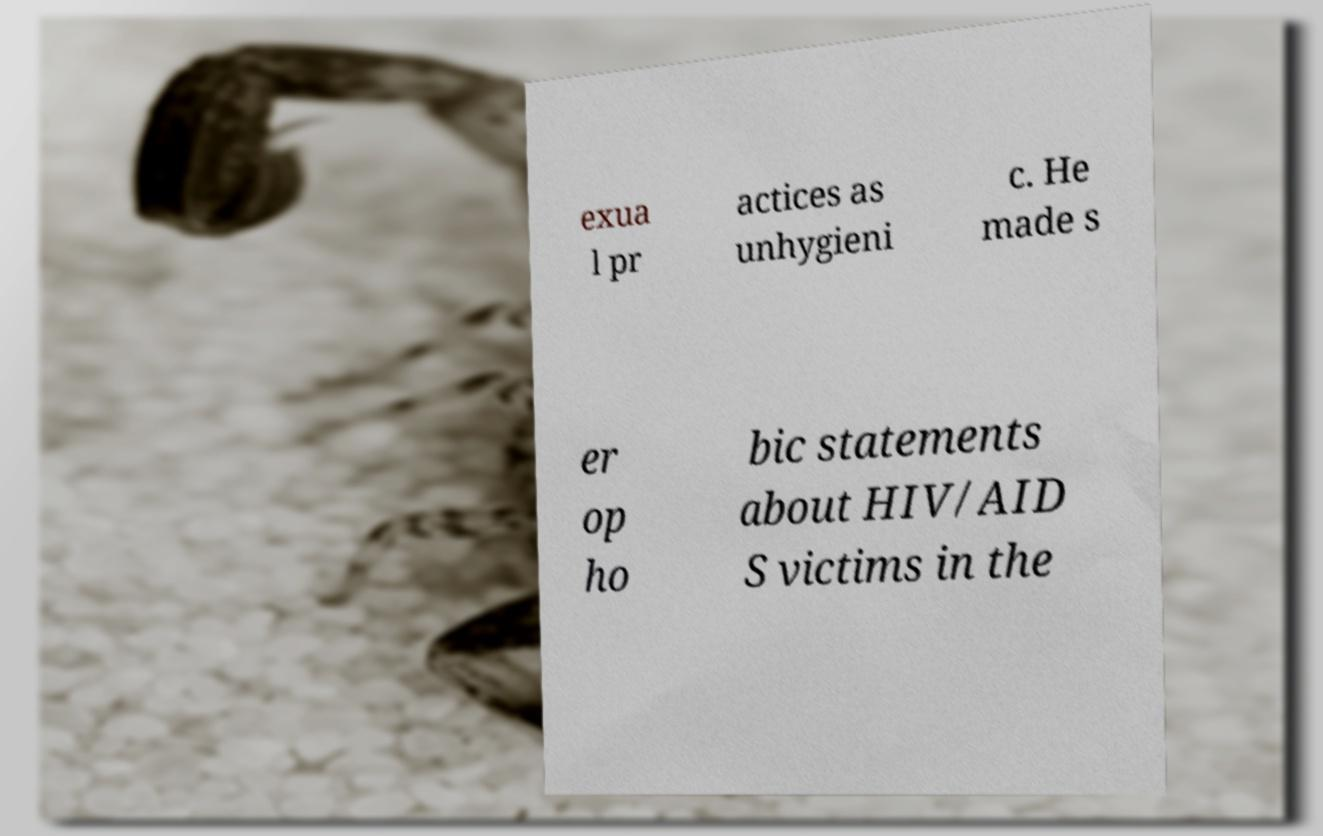Could you assist in decoding the text presented in this image and type it out clearly? exua l pr actices as unhygieni c. He made s er op ho bic statements about HIV/AID S victims in the 